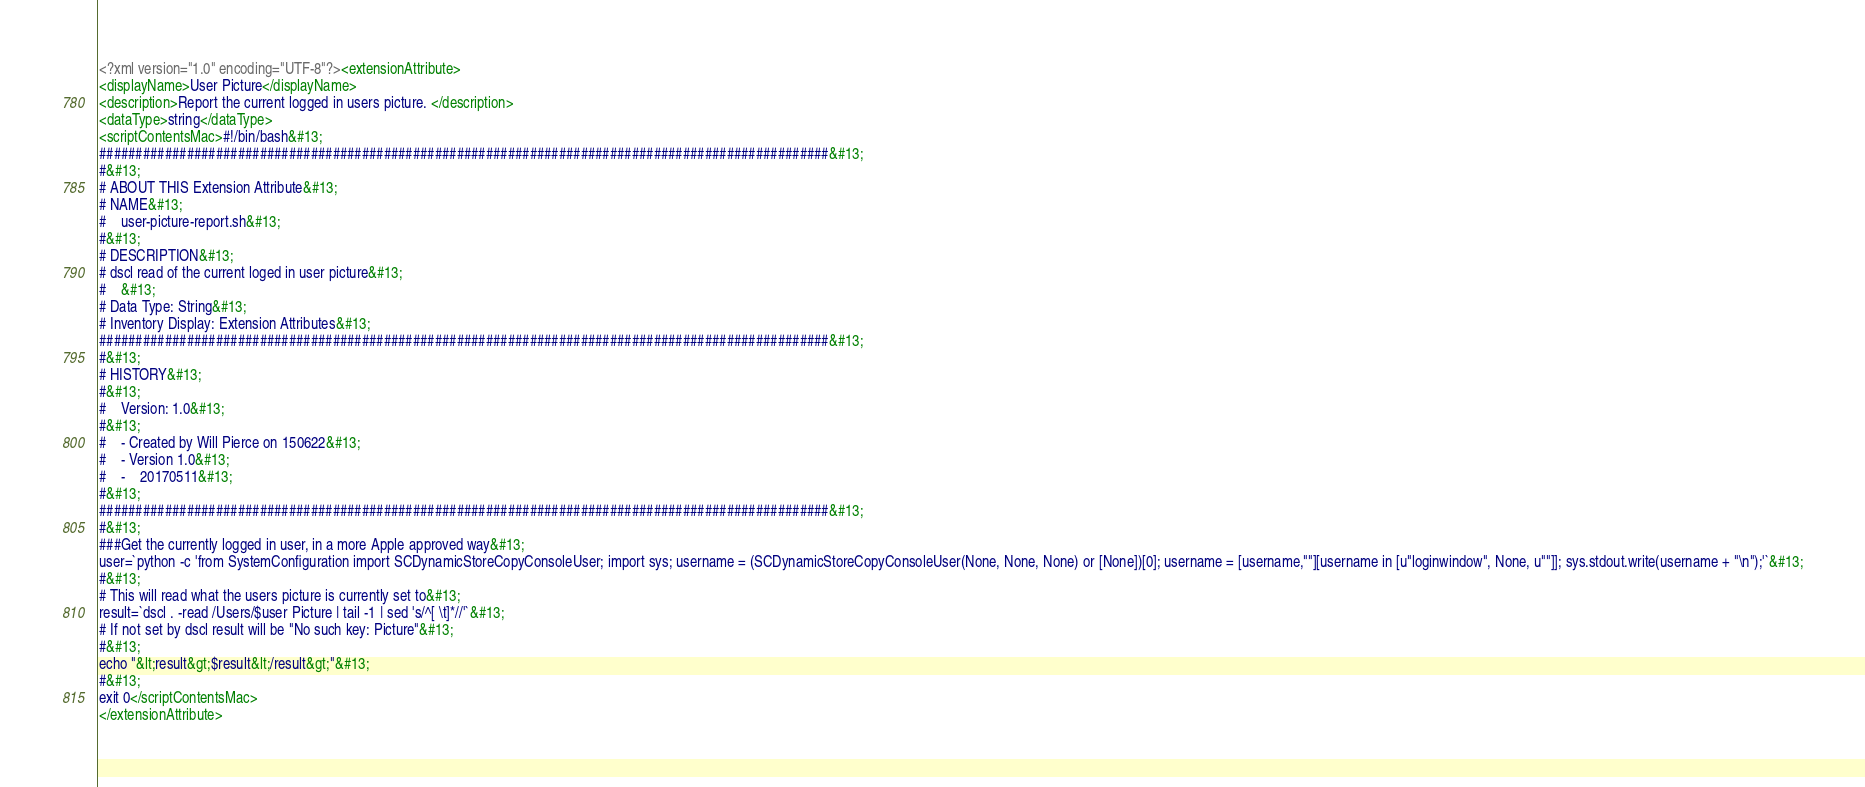<code> <loc_0><loc_0><loc_500><loc_500><_XML_><?xml version="1.0" encoding="UTF-8"?><extensionAttribute>
<displayName>User Picture</displayName>
<description>Report the current logged in users picture. </description>
<dataType>string</dataType>
<scriptContentsMac>#!/bin/bash&#13;
####################################################################################################&#13;
#&#13;
# ABOUT THIS Extension Attribute&#13;
# NAME&#13;
#	user-picture-report.sh&#13;
#&#13;
# DESCRIPTION&#13;
# dscl read of the current loged in user picture&#13;
#	&#13;
# Data Type: String&#13;
# Inventory Display: Extension Attributes&#13;
####################################################################################################&#13;
#&#13;
# HISTORY&#13;
#&#13;
#	Version: 1.0&#13;
#&#13;
#	- Created by Will Pierce on 150622&#13;
#	- Version 1.0&#13;
#	-	20170511&#13;
#&#13;
####################################################################################################&#13;
#&#13;
###Get the currently logged in user, in a more Apple approved way&#13;
user=`python -c 'from SystemConfiguration import SCDynamicStoreCopyConsoleUser; import sys; username = (SCDynamicStoreCopyConsoleUser(None, None, None) or [None])[0]; username = [username,""][username in [u"loginwindow", None, u""]]; sys.stdout.write(username + "\n");'`&#13;
#&#13;
# This will read what the users picture is currently set to&#13;
result=`dscl . -read /Users/$user Picture | tail -1 | sed 's/^[ \t]*//'`&#13;
# If not set by dscl result will be "No such key: Picture"&#13;
#&#13;
echo "&lt;result&gt;$result&lt;/result&gt;"&#13;
#&#13;
exit 0</scriptContentsMac>
</extensionAttribute>
</code> 